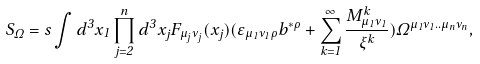Convert formula to latex. <formula><loc_0><loc_0><loc_500><loc_500>S _ { \Omega } = s \int d ^ { 3 } x _ { 1 } \prod _ { j = 2 } ^ { n } d ^ { 3 } x _ { j } F _ { \mu _ { j } \nu _ { j } } ( x _ { j } ) ( \varepsilon _ { \mu _ { 1 } \nu _ { 1 } \rho } b ^ { * \rho } + \sum _ { k = 1 } ^ { \infty } \frac { M _ { \mu _ { 1 } \nu _ { 1 } } ^ { k } } { \xi ^ { k } } ) \Omega ^ { \mu _ { 1 } \nu _ { 1 } . . \mu _ { n } \nu _ { n } } ,</formula> 